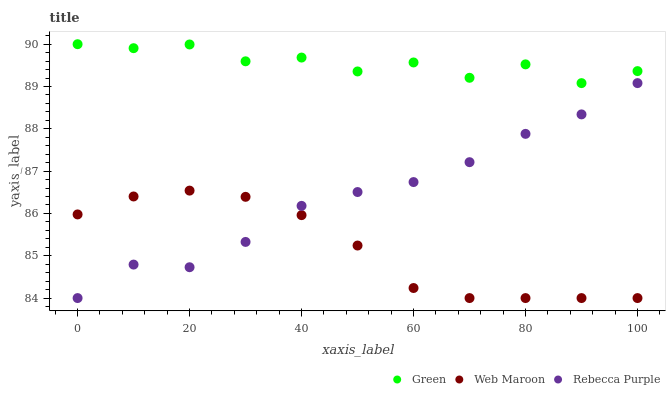Does Web Maroon have the minimum area under the curve?
Answer yes or no. Yes. Does Green have the maximum area under the curve?
Answer yes or no. Yes. Does Rebecca Purple have the minimum area under the curve?
Answer yes or no. No. Does Rebecca Purple have the maximum area under the curve?
Answer yes or no. No. Is Web Maroon the smoothest?
Answer yes or no. Yes. Is Green the roughest?
Answer yes or no. Yes. Is Rebecca Purple the smoothest?
Answer yes or no. No. Is Rebecca Purple the roughest?
Answer yes or no. No. Does Web Maroon have the lowest value?
Answer yes or no. Yes. Does Green have the lowest value?
Answer yes or no. No. Does Green have the highest value?
Answer yes or no. Yes. Does Rebecca Purple have the highest value?
Answer yes or no. No. Is Web Maroon less than Green?
Answer yes or no. Yes. Is Green greater than Rebecca Purple?
Answer yes or no. Yes. Does Web Maroon intersect Rebecca Purple?
Answer yes or no. Yes. Is Web Maroon less than Rebecca Purple?
Answer yes or no. No. Is Web Maroon greater than Rebecca Purple?
Answer yes or no. No. Does Web Maroon intersect Green?
Answer yes or no. No. 